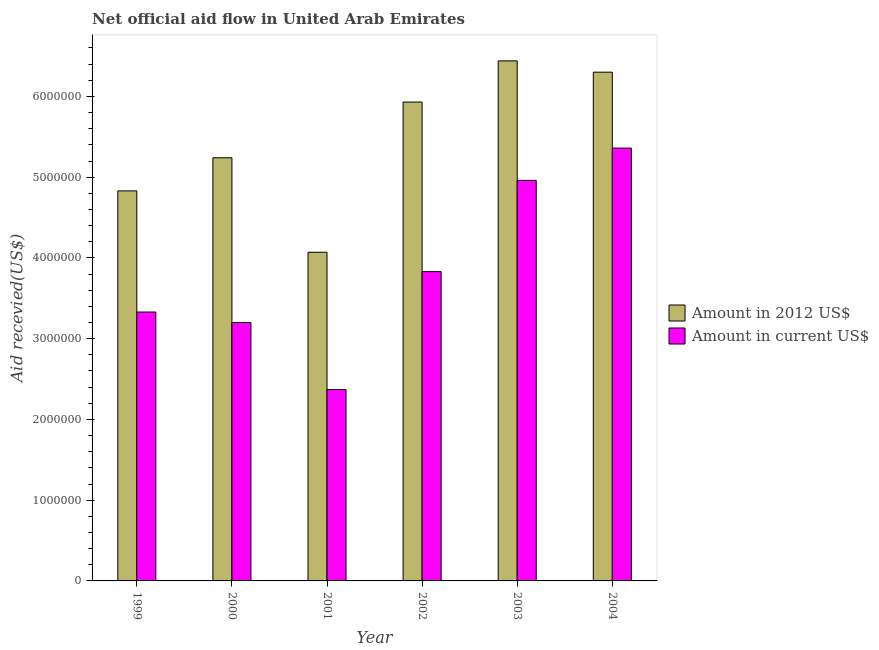How many different coloured bars are there?
Your answer should be compact. 2. How many bars are there on the 6th tick from the left?
Provide a succinct answer. 2. What is the label of the 5th group of bars from the left?
Provide a succinct answer. 2003. In how many cases, is the number of bars for a given year not equal to the number of legend labels?
Give a very brief answer. 0. What is the amount of aid received(expressed in us$) in 2004?
Your answer should be very brief. 5.36e+06. Across all years, what is the maximum amount of aid received(expressed in 2012 us$)?
Give a very brief answer. 6.44e+06. Across all years, what is the minimum amount of aid received(expressed in 2012 us$)?
Make the answer very short. 4.07e+06. In which year was the amount of aid received(expressed in us$) maximum?
Make the answer very short. 2004. What is the total amount of aid received(expressed in 2012 us$) in the graph?
Ensure brevity in your answer.  3.28e+07. What is the difference between the amount of aid received(expressed in us$) in 2001 and that in 2002?
Provide a short and direct response. -1.46e+06. What is the difference between the amount of aid received(expressed in 2012 us$) in 2004 and the amount of aid received(expressed in us$) in 1999?
Offer a very short reply. 1.47e+06. What is the average amount of aid received(expressed in 2012 us$) per year?
Your answer should be very brief. 5.47e+06. In the year 2002, what is the difference between the amount of aid received(expressed in us$) and amount of aid received(expressed in 2012 us$)?
Your answer should be very brief. 0. In how many years, is the amount of aid received(expressed in us$) greater than 1000000 US$?
Ensure brevity in your answer.  6. What is the ratio of the amount of aid received(expressed in 2012 us$) in 2000 to that in 2001?
Provide a short and direct response. 1.29. Is the difference between the amount of aid received(expressed in 2012 us$) in 2000 and 2001 greater than the difference between the amount of aid received(expressed in us$) in 2000 and 2001?
Ensure brevity in your answer.  No. What is the difference between the highest and the second highest amount of aid received(expressed in 2012 us$)?
Provide a succinct answer. 1.40e+05. What is the difference between the highest and the lowest amount of aid received(expressed in us$)?
Your answer should be very brief. 2.99e+06. In how many years, is the amount of aid received(expressed in us$) greater than the average amount of aid received(expressed in us$) taken over all years?
Offer a very short reply. 2. Is the sum of the amount of aid received(expressed in 2012 us$) in 2001 and 2002 greater than the maximum amount of aid received(expressed in us$) across all years?
Give a very brief answer. Yes. What does the 1st bar from the left in 2001 represents?
Make the answer very short. Amount in 2012 US$. What does the 1st bar from the right in 2002 represents?
Your response must be concise. Amount in current US$. Are all the bars in the graph horizontal?
Provide a short and direct response. No. What is the difference between two consecutive major ticks on the Y-axis?
Provide a short and direct response. 1.00e+06. Does the graph contain grids?
Make the answer very short. No. What is the title of the graph?
Ensure brevity in your answer.  Net official aid flow in United Arab Emirates. What is the label or title of the X-axis?
Keep it short and to the point. Year. What is the label or title of the Y-axis?
Offer a very short reply. Aid recevied(US$). What is the Aid recevied(US$) of Amount in 2012 US$ in 1999?
Your answer should be very brief. 4.83e+06. What is the Aid recevied(US$) in Amount in current US$ in 1999?
Provide a short and direct response. 3.33e+06. What is the Aid recevied(US$) of Amount in 2012 US$ in 2000?
Keep it short and to the point. 5.24e+06. What is the Aid recevied(US$) of Amount in current US$ in 2000?
Ensure brevity in your answer.  3.20e+06. What is the Aid recevied(US$) in Amount in 2012 US$ in 2001?
Your response must be concise. 4.07e+06. What is the Aid recevied(US$) in Amount in current US$ in 2001?
Your response must be concise. 2.37e+06. What is the Aid recevied(US$) of Amount in 2012 US$ in 2002?
Your answer should be compact. 5.93e+06. What is the Aid recevied(US$) in Amount in current US$ in 2002?
Make the answer very short. 3.83e+06. What is the Aid recevied(US$) of Amount in 2012 US$ in 2003?
Give a very brief answer. 6.44e+06. What is the Aid recevied(US$) of Amount in current US$ in 2003?
Ensure brevity in your answer.  4.96e+06. What is the Aid recevied(US$) of Amount in 2012 US$ in 2004?
Ensure brevity in your answer.  6.30e+06. What is the Aid recevied(US$) in Amount in current US$ in 2004?
Provide a succinct answer. 5.36e+06. Across all years, what is the maximum Aid recevied(US$) in Amount in 2012 US$?
Your response must be concise. 6.44e+06. Across all years, what is the maximum Aid recevied(US$) in Amount in current US$?
Your answer should be compact. 5.36e+06. Across all years, what is the minimum Aid recevied(US$) of Amount in 2012 US$?
Keep it short and to the point. 4.07e+06. Across all years, what is the minimum Aid recevied(US$) in Amount in current US$?
Provide a succinct answer. 2.37e+06. What is the total Aid recevied(US$) in Amount in 2012 US$ in the graph?
Your answer should be compact. 3.28e+07. What is the total Aid recevied(US$) in Amount in current US$ in the graph?
Your response must be concise. 2.30e+07. What is the difference between the Aid recevied(US$) in Amount in 2012 US$ in 1999 and that in 2000?
Provide a succinct answer. -4.10e+05. What is the difference between the Aid recevied(US$) in Amount in 2012 US$ in 1999 and that in 2001?
Offer a very short reply. 7.60e+05. What is the difference between the Aid recevied(US$) in Amount in current US$ in 1999 and that in 2001?
Provide a succinct answer. 9.60e+05. What is the difference between the Aid recevied(US$) of Amount in 2012 US$ in 1999 and that in 2002?
Provide a short and direct response. -1.10e+06. What is the difference between the Aid recevied(US$) in Amount in current US$ in 1999 and that in 2002?
Make the answer very short. -5.00e+05. What is the difference between the Aid recevied(US$) of Amount in 2012 US$ in 1999 and that in 2003?
Offer a terse response. -1.61e+06. What is the difference between the Aid recevied(US$) of Amount in current US$ in 1999 and that in 2003?
Ensure brevity in your answer.  -1.63e+06. What is the difference between the Aid recevied(US$) of Amount in 2012 US$ in 1999 and that in 2004?
Your answer should be very brief. -1.47e+06. What is the difference between the Aid recevied(US$) in Amount in current US$ in 1999 and that in 2004?
Provide a succinct answer. -2.03e+06. What is the difference between the Aid recevied(US$) in Amount in 2012 US$ in 2000 and that in 2001?
Make the answer very short. 1.17e+06. What is the difference between the Aid recevied(US$) of Amount in current US$ in 2000 and that in 2001?
Your answer should be very brief. 8.30e+05. What is the difference between the Aid recevied(US$) in Amount in 2012 US$ in 2000 and that in 2002?
Ensure brevity in your answer.  -6.90e+05. What is the difference between the Aid recevied(US$) of Amount in current US$ in 2000 and that in 2002?
Your response must be concise. -6.30e+05. What is the difference between the Aid recevied(US$) in Amount in 2012 US$ in 2000 and that in 2003?
Offer a terse response. -1.20e+06. What is the difference between the Aid recevied(US$) in Amount in current US$ in 2000 and that in 2003?
Your response must be concise. -1.76e+06. What is the difference between the Aid recevied(US$) of Amount in 2012 US$ in 2000 and that in 2004?
Keep it short and to the point. -1.06e+06. What is the difference between the Aid recevied(US$) in Amount in current US$ in 2000 and that in 2004?
Your answer should be very brief. -2.16e+06. What is the difference between the Aid recevied(US$) of Amount in 2012 US$ in 2001 and that in 2002?
Ensure brevity in your answer.  -1.86e+06. What is the difference between the Aid recevied(US$) of Amount in current US$ in 2001 and that in 2002?
Provide a short and direct response. -1.46e+06. What is the difference between the Aid recevied(US$) of Amount in 2012 US$ in 2001 and that in 2003?
Your answer should be very brief. -2.37e+06. What is the difference between the Aid recevied(US$) of Amount in current US$ in 2001 and that in 2003?
Keep it short and to the point. -2.59e+06. What is the difference between the Aid recevied(US$) in Amount in 2012 US$ in 2001 and that in 2004?
Offer a very short reply. -2.23e+06. What is the difference between the Aid recevied(US$) in Amount in current US$ in 2001 and that in 2004?
Your response must be concise. -2.99e+06. What is the difference between the Aid recevied(US$) of Amount in 2012 US$ in 2002 and that in 2003?
Keep it short and to the point. -5.10e+05. What is the difference between the Aid recevied(US$) of Amount in current US$ in 2002 and that in 2003?
Provide a short and direct response. -1.13e+06. What is the difference between the Aid recevied(US$) in Amount in 2012 US$ in 2002 and that in 2004?
Your answer should be compact. -3.70e+05. What is the difference between the Aid recevied(US$) in Amount in current US$ in 2002 and that in 2004?
Provide a short and direct response. -1.53e+06. What is the difference between the Aid recevied(US$) of Amount in 2012 US$ in 2003 and that in 2004?
Offer a very short reply. 1.40e+05. What is the difference between the Aid recevied(US$) in Amount in current US$ in 2003 and that in 2004?
Your answer should be very brief. -4.00e+05. What is the difference between the Aid recevied(US$) of Amount in 2012 US$ in 1999 and the Aid recevied(US$) of Amount in current US$ in 2000?
Give a very brief answer. 1.63e+06. What is the difference between the Aid recevied(US$) in Amount in 2012 US$ in 1999 and the Aid recevied(US$) in Amount in current US$ in 2001?
Ensure brevity in your answer.  2.46e+06. What is the difference between the Aid recevied(US$) in Amount in 2012 US$ in 1999 and the Aid recevied(US$) in Amount in current US$ in 2003?
Provide a succinct answer. -1.30e+05. What is the difference between the Aid recevied(US$) of Amount in 2012 US$ in 1999 and the Aid recevied(US$) of Amount in current US$ in 2004?
Your response must be concise. -5.30e+05. What is the difference between the Aid recevied(US$) in Amount in 2012 US$ in 2000 and the Aid recevied(US$) in Amount in current US$ in 2001?
Ensure brevity in your answer.  2.87e+06. What is the difference between the Aid recevied(US$) in Amount in 2012 US$ in 2000 and the Aid recevied(US$) in Amount in current US$ in 2002?
Keep it short and to the point. 1.41e+06. What is the difference between the Aid recevied(US$) in Amount in 2012 US$ in 2001 and the Aid recevied(US$) in Amount in current US$ in 2002?
Your answer should be very brief. 2.40e+05. What is the difference between the Aid recevied(US$) in Amount in 2012 US$ in 2001 and the Aid recevied(US$) in Amount in current US$ in 2003?
Provide a succinct answer. -8.90e+05. What is the difference between the Aid recevied(US$) of Amount in 2012 US$ in 2001 and the Aid recevied(US$) of Amount in current US$ in 2004?
Keep it short and to the point. -1.29e+06. What is the difference between the Aid recevied(US$) of Amount in 2012 US$ in 2002 and the Aid recevied(US$) of Amount in current US$ in 2003?
Make the answer very short. 9.70e+05. What is the difference between the Aid recevied(US$) in Amount in 2012 US$ in 2002 and the Aid recevied(US$) in Amount in current US$ in 2004?
Provide a succinct answer. 5.70e+05. What is the difference between the Aid recevied(US$) of Amount in 2012 US$ in 2003 and the Aid recevied(US$) of Amount in current US$ in 2004?
Ensure brevity in your answer.  1.08e+06. What is the average Aid recevied(US$) of Amount in 2012 US$ per year?
Your response must be concise. 5.47e+06. What is the average Aid recevied(US$) in Amount in current US$ per year?
Make the answer very short. 3.84e+06. In the year 1999, what is the difference between the Aid recevied(US$) in Amount in 2012 US$ and Aid recevied(US$) in Amount in current US$?
Keep it short and to the point. 1.50e+06. In the year 2000, what is the difference between the Aid recevied(US$) in Amount in 2012 US$ and Aid recevied(US$) in Amount in current US$?
Your answer should be very brief. 2.04e+06. In the year 2001, what is the difference between the Aid recevied(US$) in Amount in 2012 US$ and Aid recevied(US$) in Amount in current US$?
Offer a very short reply. 1.70e+06. In the year 2002, what is the difference between the Aid recevied(US$) of Amount in 2012 US$ and Aid recevied(US$) of Amount in current US$?
Offer a very short reply. 2.10e+06. In the year 2003, what is the difference between the Aid recevied(US$) in Amount in 2012 US$ and Aid recevied(US$) in Amount in current US$?
Your response must be concise. 1.48e+06. In the year 2004, what is the difference between the Aid recevied(US$) in Amount in 2012 US$ and Aid recevied(US$) in Amount in current US$?
Offer a terse response. 9.40e+05. What is the ratio of the Aid recevied(US$) in Amount in 2012 US$ in 1999 to that in 2000?
Make the answer very short. 0.92. What is the ratio of the Aid recevied(US$) in Amount in current US$ in 1999 to that in 2000?
Give a very brief answer. 1.04. What is the ratio of the Aid recevied(US$) of Amount in 2012 US$ in 1999 to that in 2001?
Make the answer very short. 1.19. What is the ratio of the Aid recevied(US$) in Amount in current US$ in 1999 to that in 2001?
Make the answer very short. 1.41. What is the ratio of the Aid recevied(US$) in Amount in 2012 US$ in 1999 to that in 2002?
Your answer should be very brief. 0.81. What is the ratio of the Aid recevied(US$) of Amount in current US$ in 1999 to that in 2002?
Your answer should be compact. 0.87. What is the ratio of the Aid recevied(US$) in Amount in 2012 US$ in 1999 to that in 2003?
Your answer should be very brief. 0.75. What is the ratio of the Aid recevied(US$) of Amount in current US$ in 1999 to that in 2003?
Offer a terse response. 0.67. What is the ratio of the Aid recevied(US$) of Amount in 2012 US$ in 1999 to that in 2004?
Ensure brevity in your answer.  0.77. What is the ratio of the Aid recevied(US$) of Amount in current US$ in 1999 to that in 2004?
Offer a terse response. 0.62. What is the ratio of the Aid recevied(US$) of Amount in 2012 US$ in 2000 to that in 2001?
Keep it short and to the point. 1.29. What is the ratio of the Aid recevied(US$) of Amount in current US$ in 2000 to that in 2001?
Provide a short and direct response. 1.35. What is the ratio of the Aid recevied(US$) of Amount in 2012 US$ in 2000 to that in 2002?
Your response must be concise. 0.88. What is the ratio of the Aid recevied(US$) of Amount in current US$ in 2000 to that in 2002?
Ensure brevity in your answer.  0.84. What is the ratio of the Aid recevied(US$) of Amount in 2012 US$ in 2000 to that in 2003?
Provide a succinct answer. 0.81. What is the ratio of the Aid recevied(US$) of Amount in current US$ in 2000 to that in 2003?
Offer a terse response. 0.65. What is the ratio of the Aid recevied(US$) in Amount in 2012 US$ in 2000 to that in 2004?
Ensure brevity in your answer.  0.83. What is the ratio of the Aid recevied(US$) in Amount in current US$ in 2000 to that in 2004?
Make the answer very short. 0.6. What is the ratio of the Aid recevied(US$) in Amount in 2012 US$ in 2001 to that in 2002?
Your response must be concise. 0.69. What is the ratio of the Aid recevied(US$) in Amount in current US$ in 2001 to that in 2002?
Make the answer very short. 0.62. What is the ratio of the Aid recevied(US$) in Amount in 2012 US$ in 2001 to that in 2003?
Make the answer very short. 0.63. What is the ratio of the Aid recevied(US$) in Amount in current US$ in 2001 to that in 2003?
Provide a short and direct response. 0.48. What is the ratio of the Aid recevied(US$) in Amount in 2012 US$ in 2001 to that in 2004?
Offer a very short reply. 0.65. What is the ratio of the Aid recevied(US$) of Amount in current US$ in 2001 to that in 2004?
Offer a very short reply. 0.44. What is the ratio of the Aid recevied(US$) of Amount in 2012 US$ in 2002 to that in 2003?
Keep it short and to the point. 0.92. What is the ratio of the Aid recevied(US$) in Amount in current US$ in 2002 to that in 2003?
Your answer should be very brief. 0.77. What is the ratio of the Aid recevied(US$) in Amount in 2012 US$ in 2002 to that in 2004?
Your answer should be very brief. 0.94. What is the ratio of the Aid recevied(US$) of Amount in current US$ in 2002 to that in 2004?
Provide a succinct answer. 0.71. What is the ratio of the Aid recevied(US$) in Amount in 2012 US$ in 2003 to that in 2004?
Offer a terse response. 1.02. What is the ratio of the Aid recevied(US$) in Amount in current US$ in 2003 to that in 2004?
Ensure brevity in your answer.  0.93. What is the difference between the highest and the second highest Aid recevied(US$) in Amount in current US$?
Offer a terse response. 4.00e+05. What is the difference between the highest and the lowest Aid recevied(US$) of Amount in 2012 US$?
Your response must be concise. 2.37e+06. What is the difference between the highest and the lowest Aid recevied(US$) of Amount in current US$?
Your answer should be compact. 2.99e+06. 